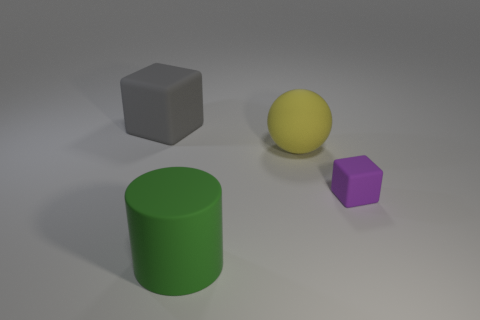There is a big thing that is in front of the rubber block that is on the right side of the large gray matte cube; what color is it?
Offer a terse response. Green. Is there a large metal cube of the same color as the matte ball?
Give a very brief answer. No. There is a green object that is the same size as the sphere; what shape is it?
Provide a short and direct response. Cylinder. There is a matte thing that is on the left side of the green rubber cylinder; what number of green cylinders are behind it?
Give a very brief answer. 0. Do the ball and the small matte thing have the same color?
Keep it short and to the point. No. How many other things are there of the same material as the ball?
Provide a short and direct response. 3. There is a big matte thing that is in front of the cube that is in front of the gray thing; what is its shape?
Make the answer very short. Cylinder. There is a object behind the rubber ball; what is its size?
Provide a succinct answer. Large. Do the yellow object and the big cube have the same material?
Give a very brief answer. Yes. There is a big gray thing that is made of the same material as the purple thing; what shape is it?
Make the answer very short. Cube. 